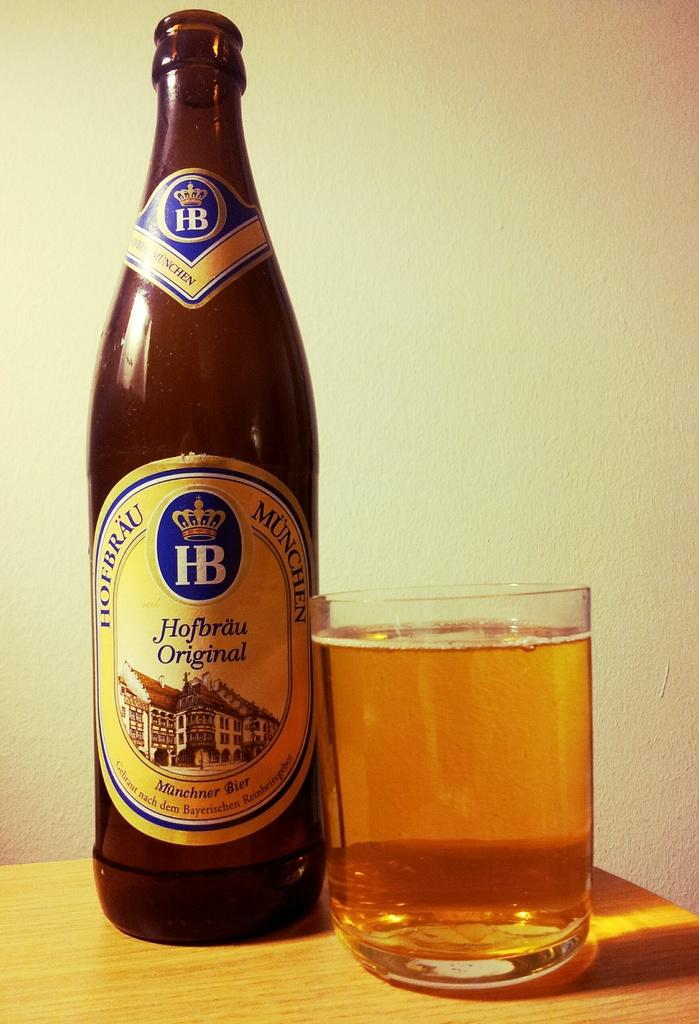Provide a one-sentence caption for the provided image. A bottle of Hofbrau Original beer has been poured into a drinking glass beside it. 